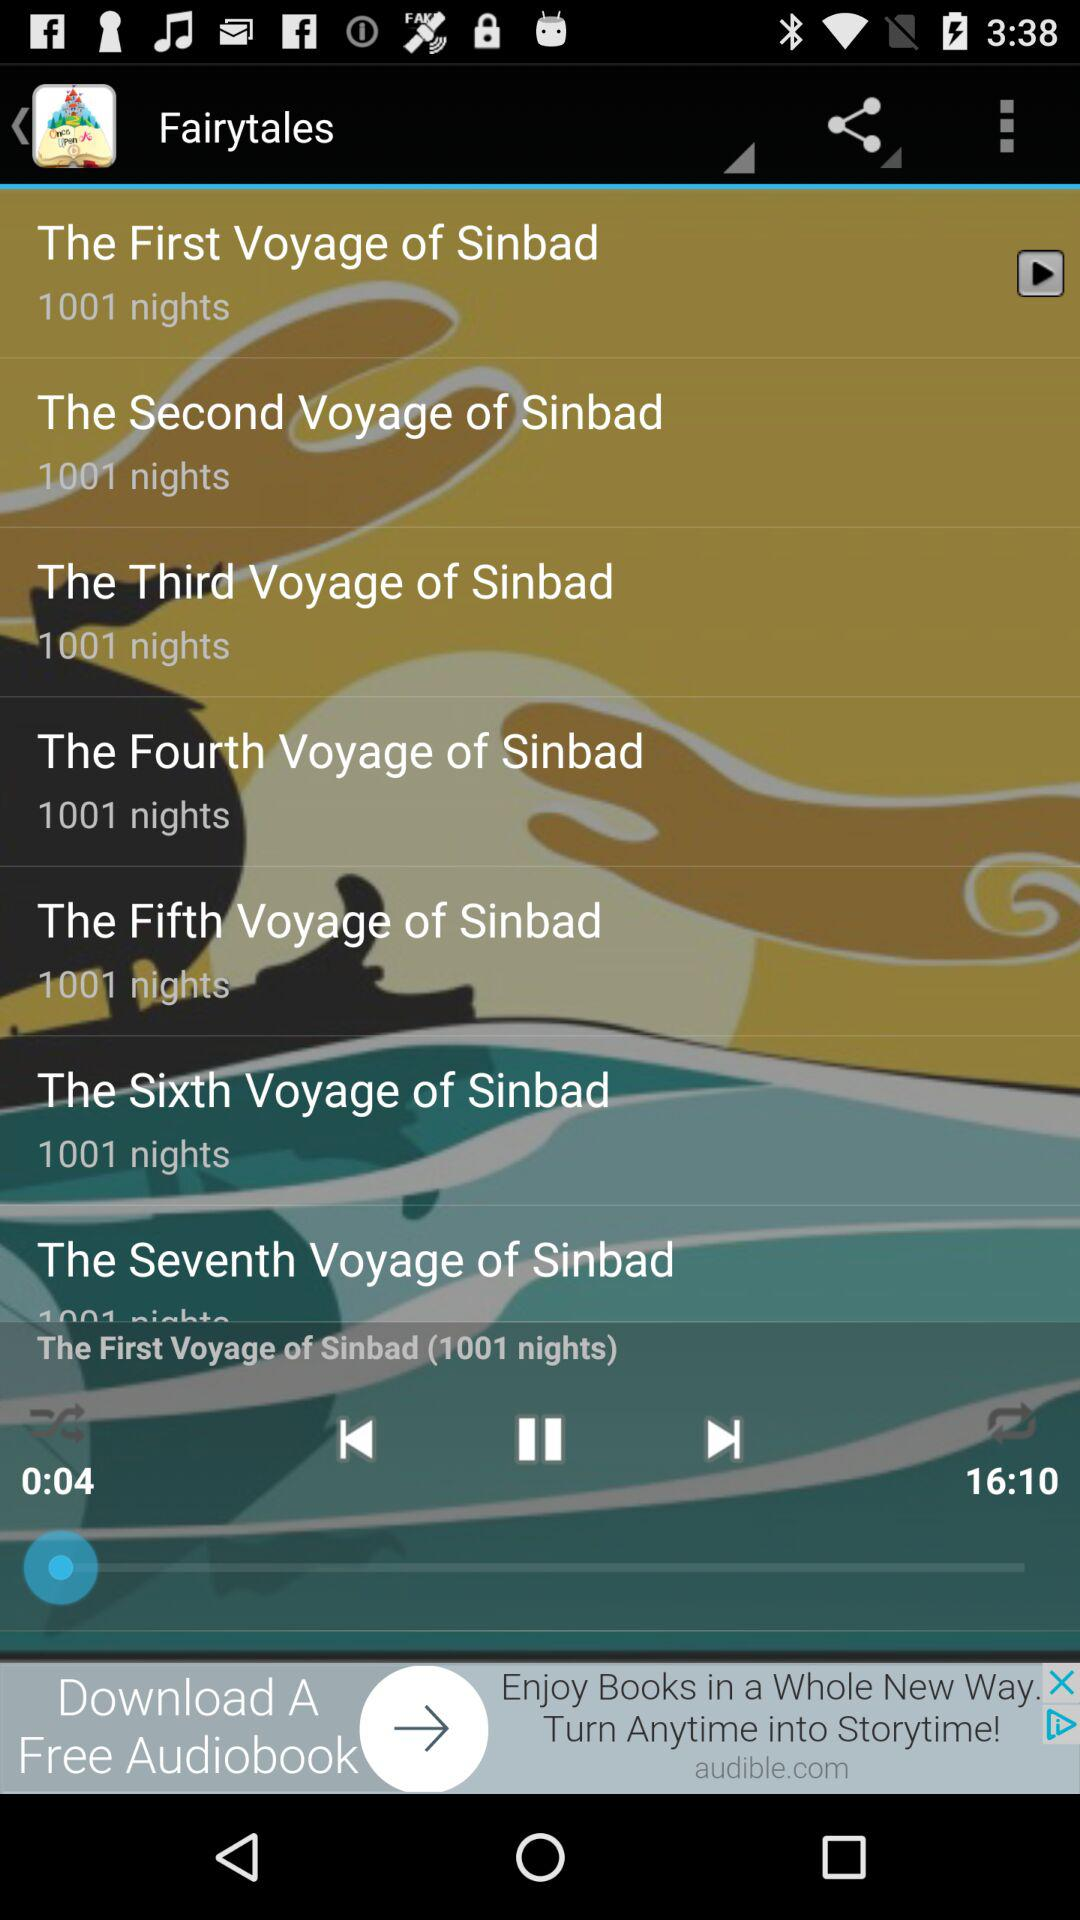How many more episodes are there after The First Voyage of Sinbad?
Answer the question using a single word or phrase. 6 